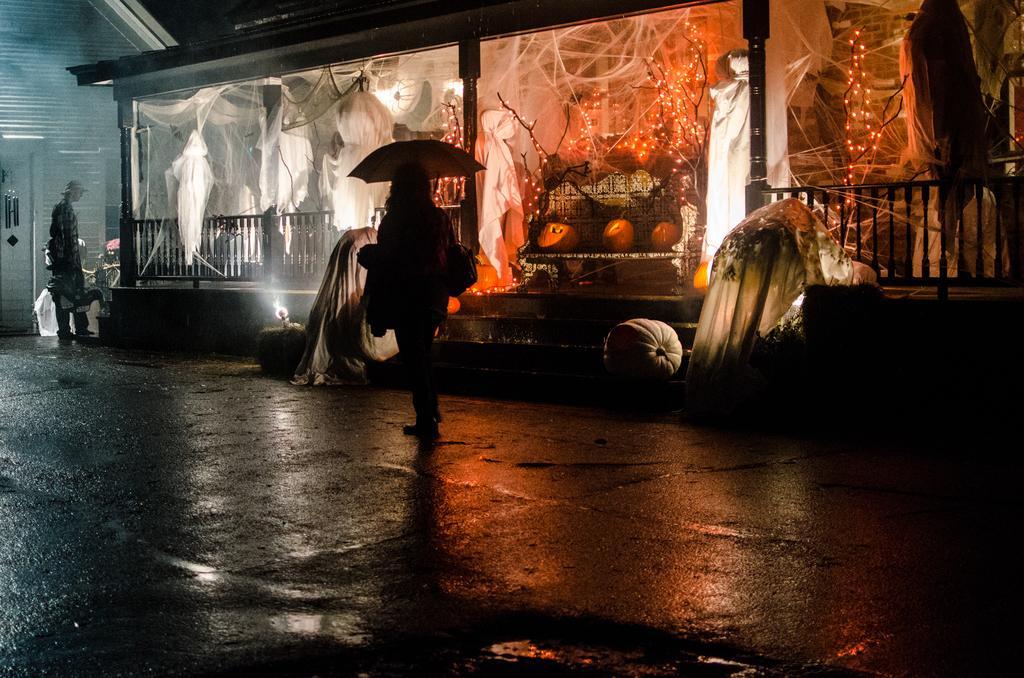Please provide a concise description of this image. In this picture we can see the glasses. We can see the decoration with clothes, branches, lights and few other objects. We can see the railing, stairs, clothes and objects near a woman. We can see a woman is wearing a handbag, holding an umbrella. On the left side of the picture we can see a man standing, wearing a hat. We can see a house, wind chime. At the bottom portion of the picture we can see the road. 